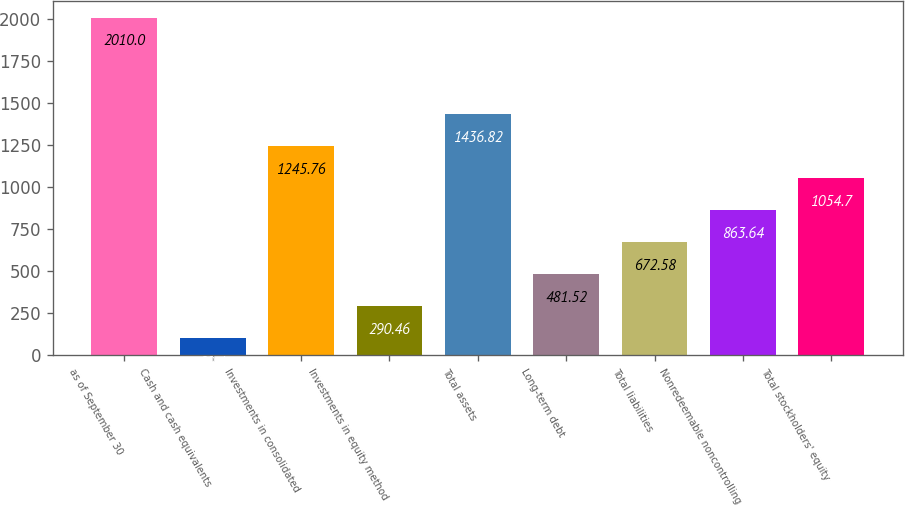Convert chart to OTSL. <chart><loc_0><loc_0><loc_500><loc_500><bar_chart><fcel>as of September 30<fcel>Cash and cash equivalents<fcel>Investments in consolidated<fcel>Investments in equity method<fcel>Total assets<fcel>Long-term debt<fcel>Total liabilities<fcel>Nonredeemable noncontrolling<fcel>Total stockholders' equity<nl><fcel>2010<fcel>99.4<fcel>1245.76<fcel>290.46<fcel>1436.82<fcel>481.52<fcel>672.58<fcel>863.64<fcel>1054.7<nl></chart> 